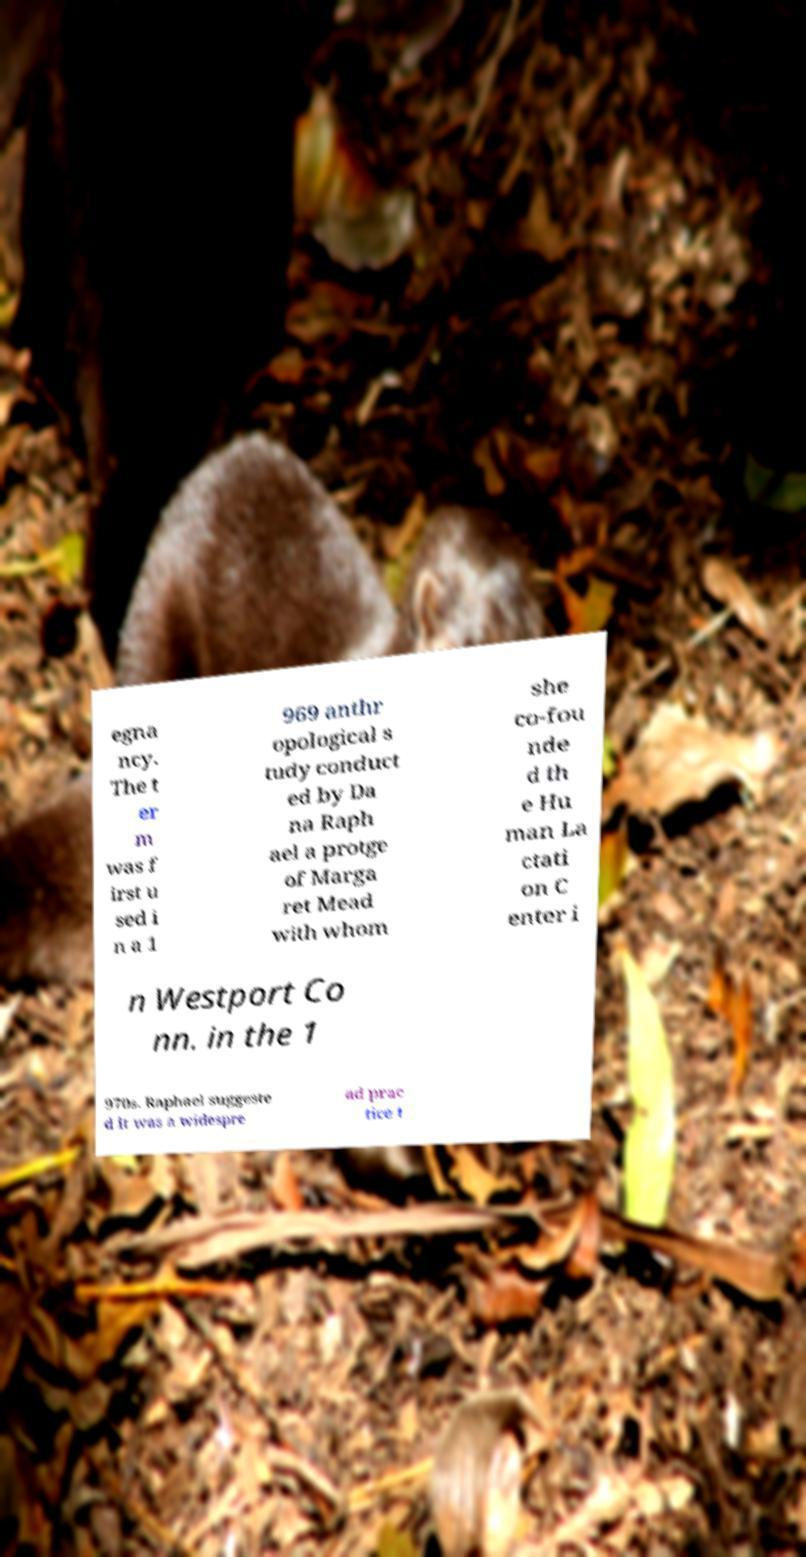I need the written content from this picture converted into text. Can you do that? egna ncy. The t er m was f irst u sed i n a 1 969 anthr opological s tudy conduct ed by Da na Raph ael a protge of Marga ret Mead with whom she co-fou nde d th e Hu man La ctati on C enter i n Westport Co nn. in the 1 970s. Raphael suggeste d it was a widespre ad prac tice t 